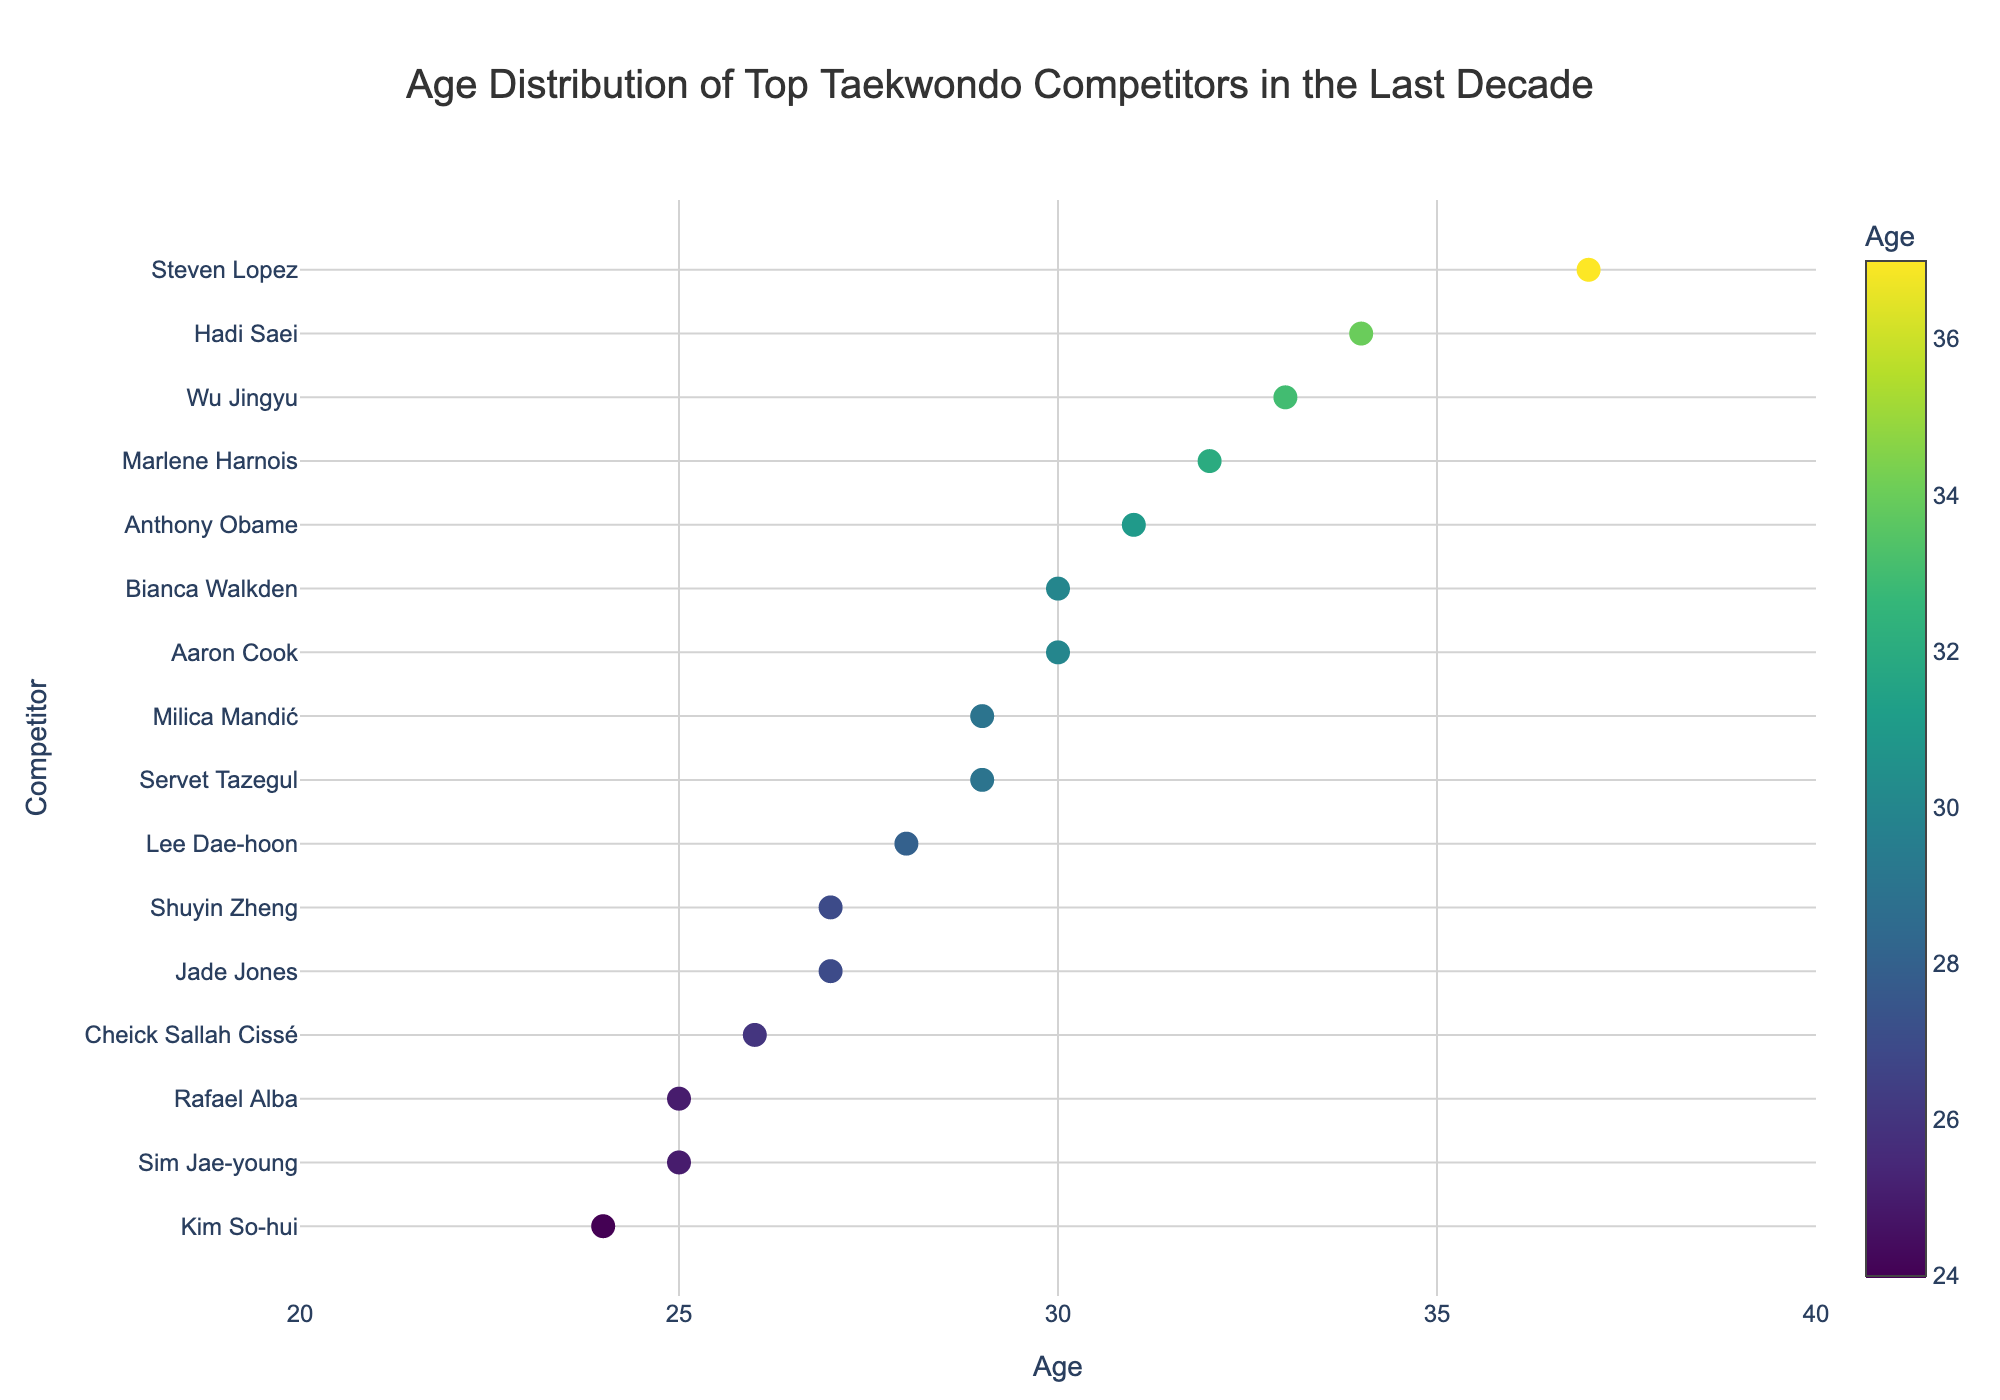What is the title of the plot? The title is displayed at the top center of the plot and reads "Age Distribution of Top Taekwondo Competitors in the Last Decade".
Answer: Age Distribution of Top Taekwondo Competitors in the Last Decade How many competitors are represented in the plot? The plot has one dot for each competitor, and you can count the total number of dots. There are a total of 15 competitors represented.
Answer: 15 Which competitor is the youngest? By looking at the age axis and finding the smallest dot, you can see that Kim So-hui from South Korea is the youngest competitor, aged 24.
Answer: Kim So-hui Who is the oldest competitor and what is their age? The oldest competitor can be identified by looking for the highest age on the axis. Steven Lopez from the USA is the oldest, and he is 37 years old.
Answer: Steven Lopez, 37 What is the age range of the competitors in the plot? To find the age range, subtract the youngest age from the oldest age. The oldest competitor is 37 and the youngest is 24, so the range is 37 - 24 = 13 years.
Answer: 13 years How many competitors are aged 30 or above? Count the dots that are at age 30 or above on the x-axis. Aaron Cook, Bianca Walkden, Hadi Saei, Marlene Harnois, Wu Jingyu, and Steven Lopez make a total of 6 competitors aged 30 or above.
Answer: 6 Compare the ages of Lee Dae-hoon and Milica Mandić, who is older? Locate the dots corresponding to Lee Dae-hoon and Milica Mandić on the age axis. Lee Dae-hoon is 28 years old, and Milica Mandić is 29 years old, making Milica Mandić older.
Answer: Milica Mandić What is the average age of all competitors in the plot? To find the average age, sum up all the ages and then divide by the number of competitors. The ages sum up to 448. Dividing 448 by 15 results in an average age of approximately 29.87 years.
Answer: 29.87 years Which country has the most competitors represented in the plot, and how many are there? Identify the countries for each dot. South Korea is mentioned three times (Lee Dae-hoon, Sim Jae-young, Kim So-hui), making it the country with the highest representation.
Answer: South Korea, 3 competitors How many female competitors are aged 30 or older? First, identify the female competitors and check if their ages are 30 or above by looking at the age axis and their names: Jade Jones, Wu Jingyu, Marlene Harnois, and Bianca Walkden. There are 4 female competitors aged 30 or older.
Answer: 4 